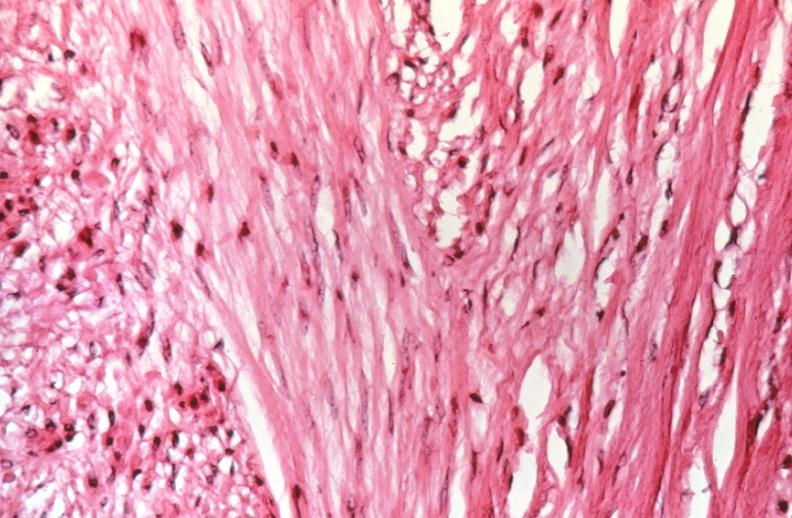what does this image show?
Answer the question using a single word or phrase. Uterus 